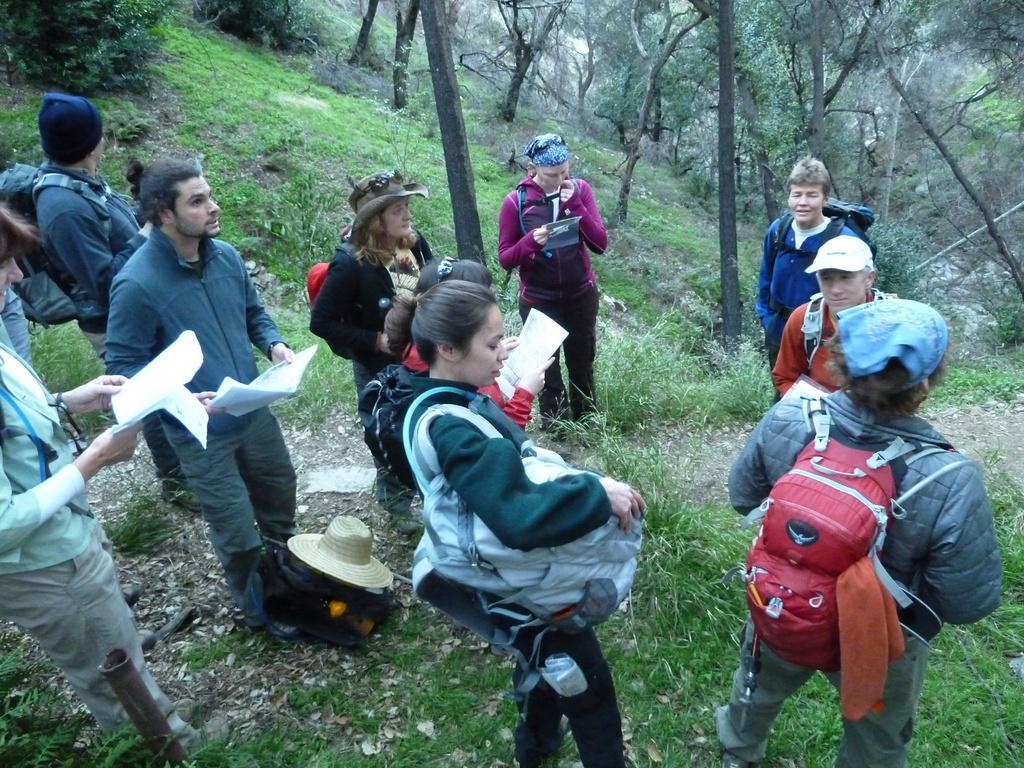Can you describe this image briefly? In the image there are group of people standing on the grass. All of them are wearing backpacks and few people are holding some papers in their hand,behind the people there are plenty of trees. 